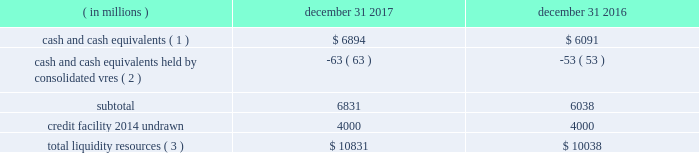Sources of blackrock 2019s operating cash primarily include investment advisory , administration fees and securities lending revenue , performance fees , revenue from technology and risk management services , advisory and other revenue and distribution fees .
Blackrock uses its cash to pay all operating expense , interest and principal on borrowings , income taxes , dividends on blackrock 2019s capital stock , repurchases of the company 2019s stock , capital expenditures and purchases of co-investments and seed investments .
For details of the company 2019s gaap cash flows from operating , investing and financing activities , see the consolidated statements of cash flows contained in part ii , item 8 of this filing .
Cash flows from operating activities , excluding the impact of consolidated sponsored investment funds , primarily include the receipt of investment advisory and administration fees , securities lending revenue and performance fees offset by the payment of operating expenses incurred in the normal course of business , including year-end incentive compensation accrued for in the prior year .
Cash outflows from investing activities , excluding the impact of consolidated sponsored investment funds , for 2017 were $ 517 million and primarily reflected $ 497 million of investment purchases , $ 155 million of purchases of property and equipment , $ 73 million related to the first reserve transaction and $ 29 million related to the cachematrix transaction , partially offset by $ 205 million of net proceeds from sales and maturities of certain investments .
Cash outflows from financing activities , excluding the impact of consolidated sponsored investment funds , for 2017 were $ 3094 million , primarily resulting from $ 1.4 billion of share repurchases , including $ 1.1 billion in open market- transactions and $ 321 million of employee tax withholdings related to employee stock transactions , $ 1.7 billion of cash dividend payments and $ 700 million of repayments of long- term borrowings , partially offset by $ 697 million of proceeds from issuance of long-term borrowings .
The company manages its financial condition and funding to maintain appropriate liquidity for the business .
Liquidity resources at december 31 , 2017 and 2016 were as follows : ( in millions ) december 31 , december 31 , cash and cash equivalents ( 1 ) $ 6894 $ 6091 cash and cash equivalents held by consolidated vres ( 2 ) ( 63 ) ( 53 ) .
Total liquidity resources ( 3 ) $ 10831 $ 10038 ( 1 ) the percentage of cash and cash equivalents held by the company 2019s u.s .
Subsidiaries was approximately 40% ( 40 % ) and 50% ( 50 % ) at december 31 , 2017 and 2016 , respectively .
See net capital requirements herein for more information on net capital requirements in certain regulated subsidiaries .
( 2 ) the company cannot readily access such cash to use in its operating activities .
( 3 ) amounts do not reflect a reduction for year-end incentive compensation accruals of approximately $ 1.5 billion and $ 1.3 billion for 2017 and 2016 , respectively , which are paid in the first quarter of the following year .
Total liquidity resources increased $ 793 million during 2017 , primarily reflecting cash flows from operating activities , partially offset by cash payments of 2016 year-end incentive awards , share repurchases of $ 1.4 billion and cash dividend payments of $ 1.7 billion .
A significant portion of the company 2019s $ 3154 million of total investments , as adjusted , is illiquid in nature and , as such , cannot be readily convertible to cash .
Share repurchases .
The company repurchased 2.6 million common shares in open market transactions under the share repurchase program for approximately $ 1.1 billion during 2017 .
At december 31 , 2017 , there were 6.4 million shares still authorized to be repurchased .
Net capital requirements .
The company is required to maintain net capital in certain regulated subsidiaries within a number of jurisdictions , which is partially maintained by retaining cash and cash equivalent investments in those subsidiaries or jurisdictions .
As a result , such subsidiaries of the company may be restricted in their ability to transfer cash between different jurisdictions and to their parents .
Additionally , transfers of cash between international jurisdictions may have adverse tax consequences that could discourage such transfers .
Blackrock institutional trust company , n.a .
( 201cbtc 201d ) is chartered as a national bank that does not accept client deposits and whose powers are limited to trust and other fiduciary activities .
Btc provides investment management services , including investment advisory and securities lending agency services , to institutional clients .
Btc is subject to regulatory capital and liquid asset requirements administered by the office of the comptroller of the currency .
At december 31 , 2017 and 2016 , the company was required to maintain approximately $ 1.8 billion and $ 1.4 billion , respectively , in net capital in certain regulated subsidiaries , including btc , entities regulated by the financial conduct authority and prudential regulation authority in the united kingdom , and the company 2019s broker-dealers .
The company was in compliance with all applicable regulatory net capital requirements .
Undistributed earnings of foreign subsidiaries .
As a result of the 2017 tax act and the one-time mandatory deemed repatriation tax on untaxed accumulated foreign earnings , a provisional amount of u.s .
Income taxes was provided on the undistributed foreign earnings .
The financial statement basis in excess of tax basis of its foreign subsidiaries remains indefinitely reinvested in foreign operations .
The company will continue to evaluate its capital management plans throughout 2018 .
Short-term borrowings 2017 revolving credit facility .
The company 2019s credit facility has an aggregate commitment amount of $ 4.0 billion and was amended in april 2017 to extend the maturity date to april 2022 ( the 201c2017 credit facility 201d ) .
The 2017 credit facility permits the company to request up to an additional $ 1.0 billion of borrowing capacity , subject to lender credit approval , increasing the overall size of the 2017 credit facility to an aggregate principal amount not to exceed $ 5.0 billion .
Interest on borrowings outstanding accrues at a rate based on the applicable london interbank offered rate plus a spread .
The 2017 credit facility requires the company .
What percent of 2017 liquidity comes from credit? 
Computations: (4000 / 10831)
Answer: 0.36931. 